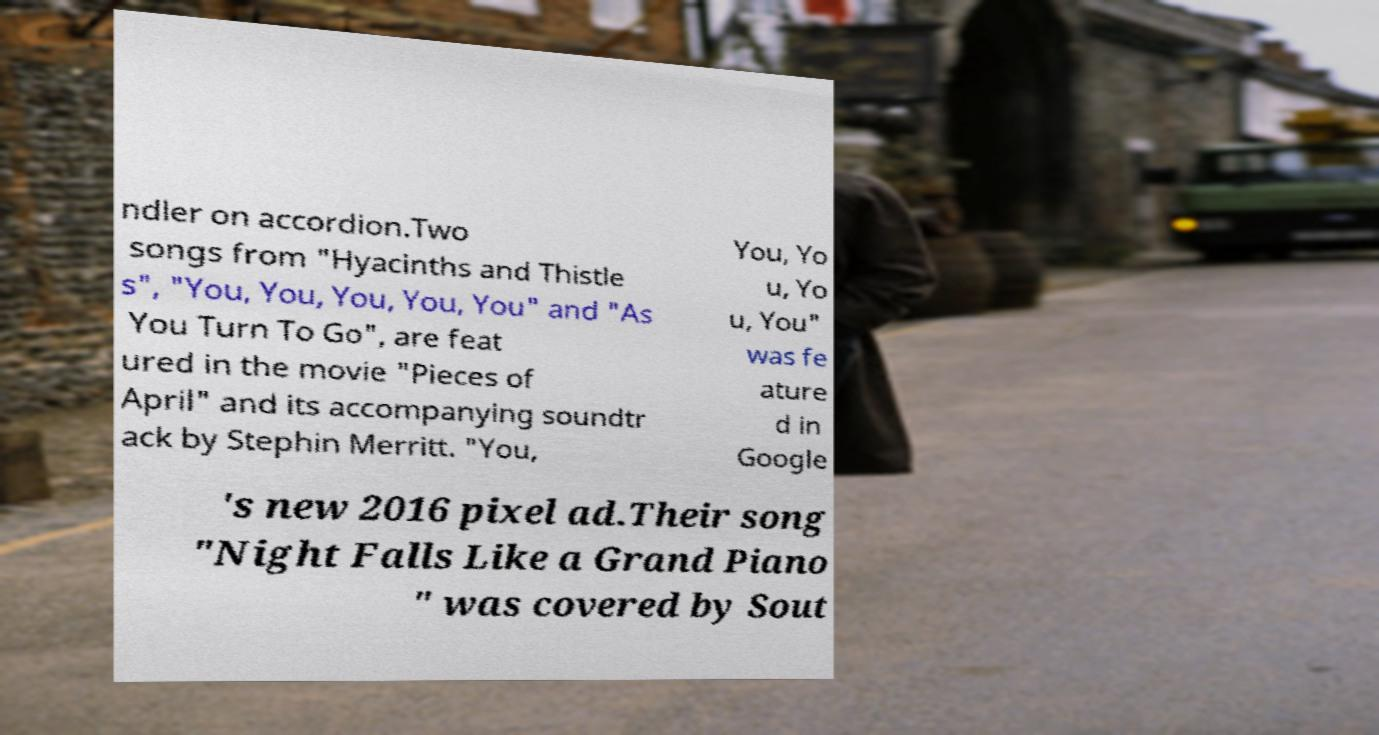I need the written content from this picture converted into text. Can you do that? ndler on accordion.Two songs from "Hyacinths and Thistle s", "You, You, You, You, You" and "As You Turn To Go", are feat ured in the movie "Pieces of April" and its accompanying soundtr ack by Stephin Merritt. "You, You, Yo u, Yo u, You" was fe ature d in Google 's new 2016 pixel ad.Their song "Night Falls Like a Grand Piano " was covered by Sout 